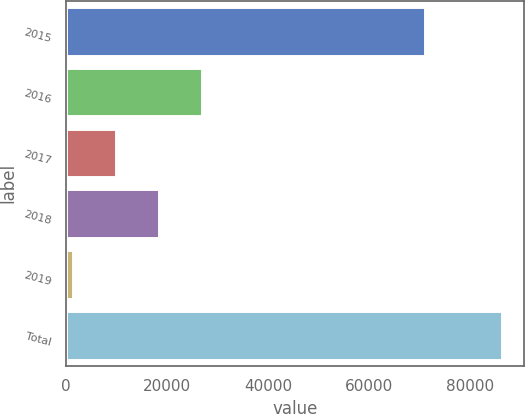Convert chart. <chart><loc_0><loc_0><loc_500><loc_500><bar_chart><fcel>2015<fcel>2016<fcel>2017<fcel>2018<fcel>2019<fcel>Total<nl><fcel>70929<fcel>26886.4<fcel>9910.8<fcel>18398.6<fcel>1423<fcel>86301<nl></chart> 